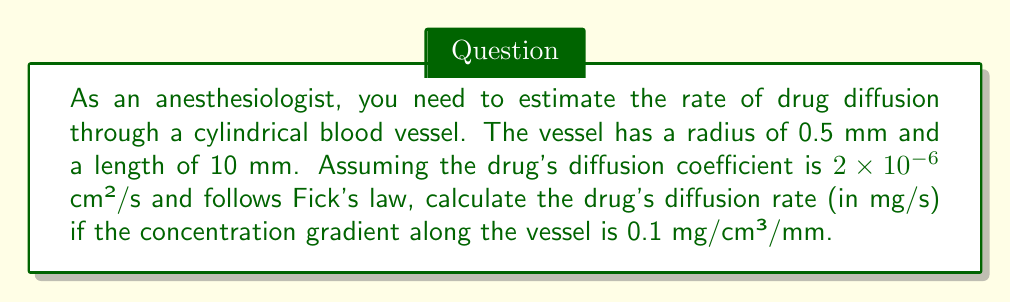Solve this math problem. To solve this problem, we'll use Fick's first law of diffusion and the geometric properties of a cylinder:

1) Fick's first law of diffusion:
   $$J = -D \frac{dC}{dx}$$
   Where:
   $J$ = diffusion flux (mg/cm²/s)
   $D$ = diffusion coefficient (cm²/s)
   $\frac{dC}{dx}$ = concentration gradient (mg/cm³/mm)

2) Convert units:
   Radius: $r = 0.5 \text{ mm} = 0.05 \text{ cm}$
   Length: $L = 10 \text{ mm} = 1 \text{ cm}$
   Concentration gradient: $0.1 \text{ mg/cm³/mm} = 1 \text{ mg/cm⁴}$

3) Calculate the diffusion flux:
   $$J = -(2 \times 10^{-6} \text{ cm²/s})(1 \text{ mg/cm⁴}) = -2 \times 10^{-6} \text{ mg/cm²/s}$$

4) Calculate the cross-sectional area of the vessel:
   $$A = \pi r^2 = \pi (0.05 \text{ cm})^2 = 7.85 \times 10^{-3} \text{ cm²}$$

5) Calculate the diffusion rate:
   $$\text{Rate} = |J| \times A = (2 \times 10^{-6} \text{ mg/cm²/s})(7.85 \times 10^{-3} \text{ cm²})$$
   $$= 1.57 \times 10^{-8} \text{ mg/s}$$
Answer: $1.57 \times 10^{-8} \text{ mg/s}$ 